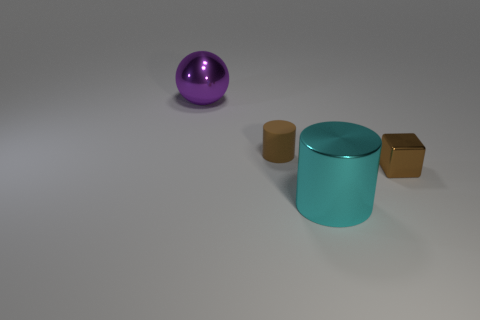Is the number of large shiny things on the left side of the cyan metal cylinder greater than the number of tiny purple cubes?
Your response must be concise. Yes. What number of tiny things are to the right of the matte thing?
Your answer should be compact. 1. Is there another cylinder of the same size as the metal cylinder?
Provide a short and direct response. No. What is the color of the other tiny object that is the same shape as the cyan metallic object?
Give a very brief answer. Brown. Does the brown cylinder to the left of the small metal object have the same size as the brown object to the right of the cyan metallic cylinder?
Offer a terse response. Yes. Is there a yellow shiny thing of the same shape as the large purple metal object?
Your response must be concise. No. Are there the same number of large purple metallic balls that are on the right side of the big purple shiny thing and large red metallic blocks?
Your answer should be compact. Yes. There is a brown cylinder; is its size the same as the cylinder in front of the tiny cylinder?
Keep it short and to the point. No. How many other brown cylinders are the same material as the large cylinder?
Keep it short and to the point. 0. Is the size of the ball the same as the block?
Ensure brevity in your answer.  No. 